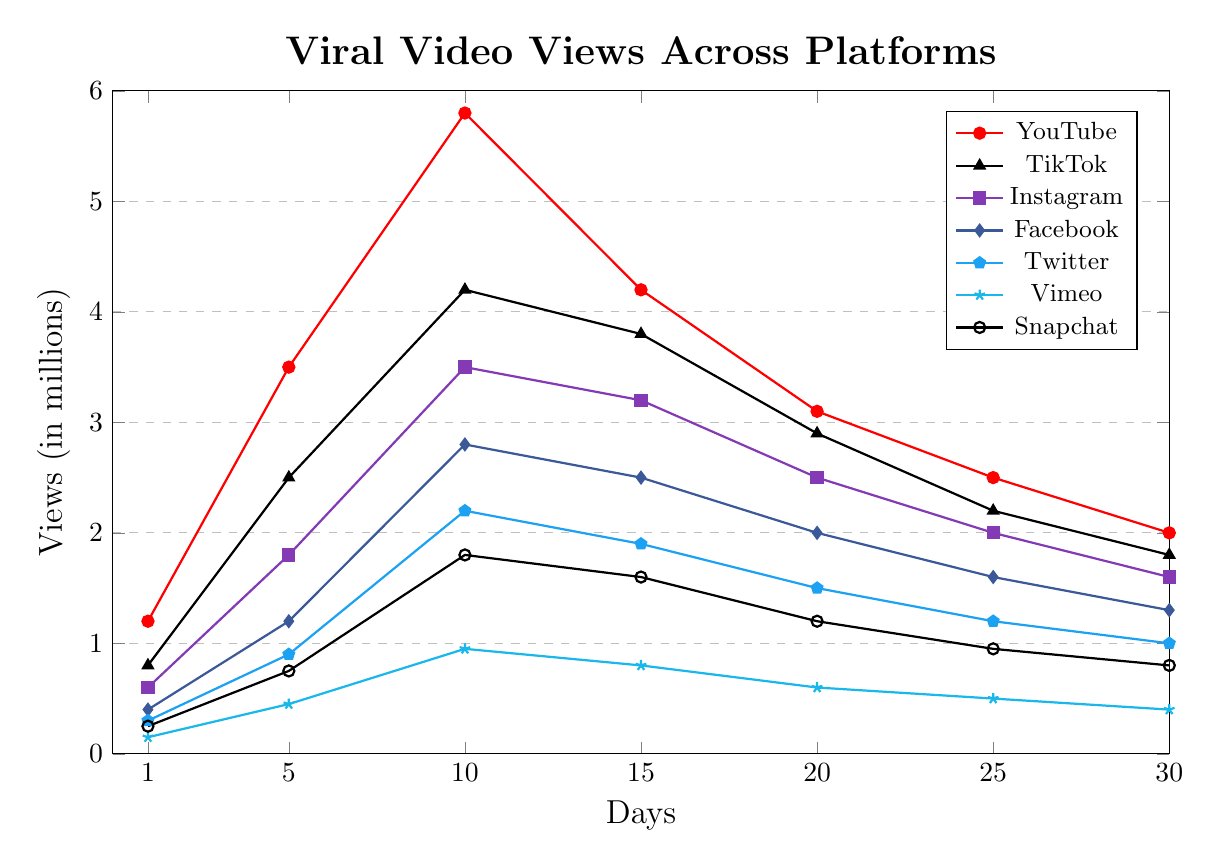What is the trend of daily views for YouTube over the 30-day period? The trend line shows an initial rise in daily views from Day 1 to Day 10, peaking around Day 10. Following this, there is a decline in views through Day 30.
Answer: Rising then declining Which platform had the highest increase in daily views between Day 1 and Day 10? To find this, we calculate the difference between Day 1 and Day 10 for each platform: YouTube: 4.6M, TikTok: 3.4M, Instagram: 2.9M, Facebook: 2.4M, Twitter: 1.9M, Vimeo: 0.8M, Snapchat: 1.55M. The highest increase is 4.6M for YouTube.
Answer: YouTube Which two platforms show a similar trend in daily views over the 30 days? TikTok and Instagram both show an increase reaching around Day 10, followed by a consistent decrease in their daily views.
Answer: TikTok and Instagram Between Day 5 and Day 20, which platform experienced the largest overall decrease in views? We calculate the difference from Day 5 to Day 20 for each: YouTube: -0.4M, TikTok: -0.6M, Instagram: -0.7M, Facebook: -0.8M, Twitter: -0.6M, Vimeo: -0.15M, Snapchat: -0.55M. The largest decrease is for Facebook.
Answer: Facebook Which platform consistently has the lowest number of views throughout the 30 days? By observing the graph, Vimeo consistently has the lowest views on each day shown.
Answer: Vimeo What is the average number of daily views on Day 25 for all platforms combined? Sum the views on Day 25 for all platforms: 2500000 (YouTube) + 2200000 (TikTok) + 2000000 (Instagram) + 1600000 (Facebook) + 1200000 (Twitter) + 500000 (Vimeo) + 950000 (Snapchat) = 10950000 views. There are 7 platforms, so the average is 10950000 / 7 ≈ 1.564M.
Answer: 1.564M Which platform saw views drop below 1 million the earliest in the timeline? From the graph, Vimeo dropped below 1 million views earliest around Day 10.
Answer: Vimeo Compare the daily views on Day 15 for Facebook and Instagram. Which one was higher and by how much? On Day 15, Facebook has 2.5M views and Instagram has 3.2M views. The difference is 3.2M - 2.5M = 0.7M.
Answer: Instagram, 0.7M How do the peak views of TikTok and Snapchat compare over the 30-day period? TikTok's peak is around 4.2M views on Day 10, while Snapchat peaks at 1.8M views also on Day 10. TikTok's peak is higher by 2.4M views.
Answer: TikTok is higher by 2.4M 